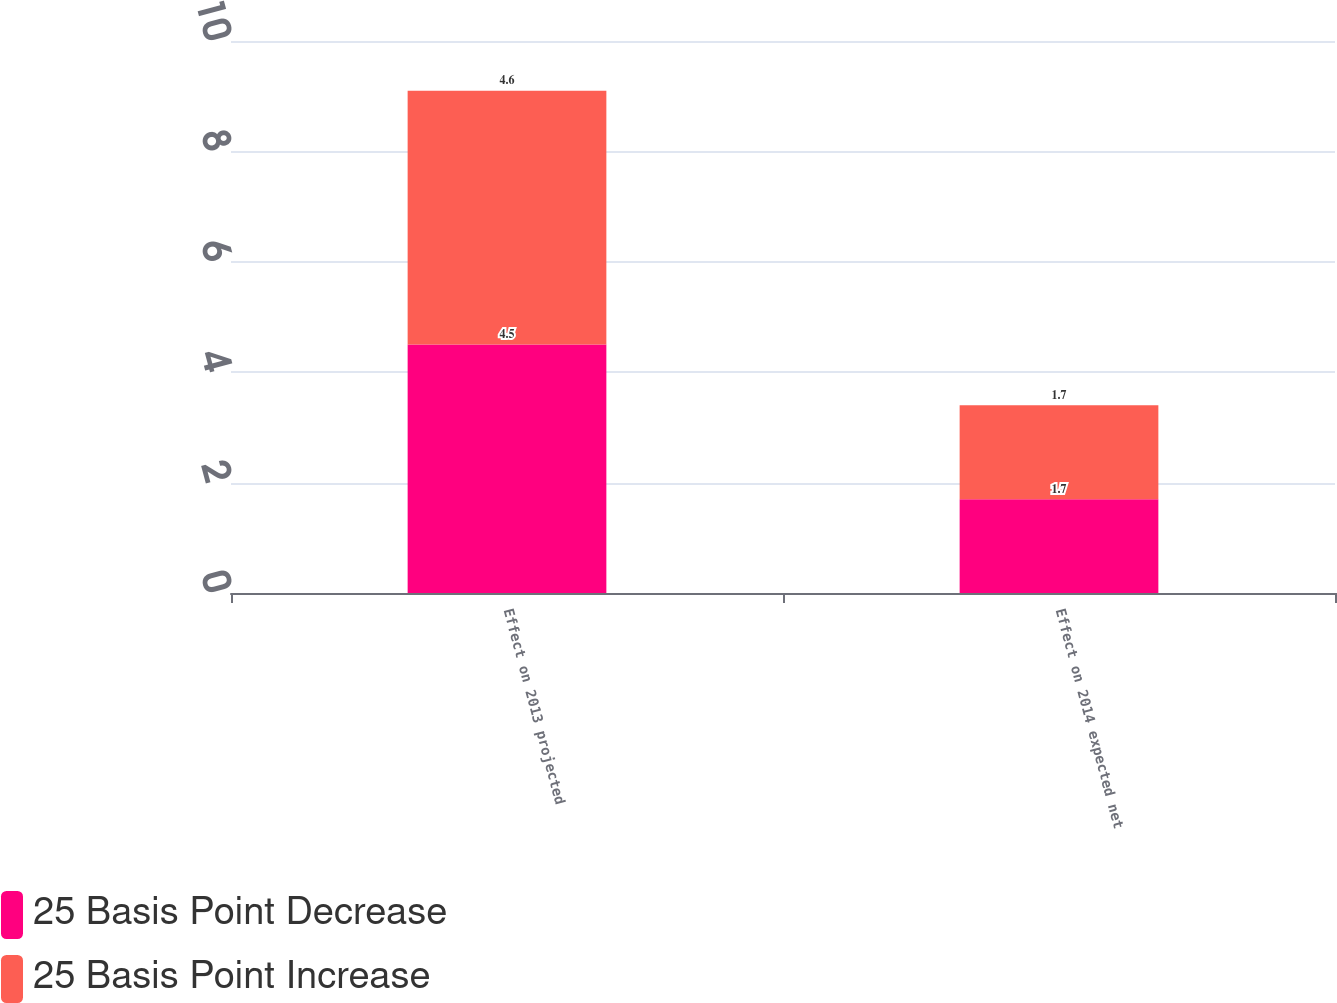<chart> <loc_0><loc_0><loc_500><loc_500><stacked_bar_chart><ecel><fcel>Effect on 2013 projected<fcel>Effect on 2014 expected net<nl><fcel>25 Basis Point Decrease<fcel>4.5<fcel>1.7<nl><fcel>25 Basis Point Increase<fcel>4.6<fcel>1.7<nl></chart> 